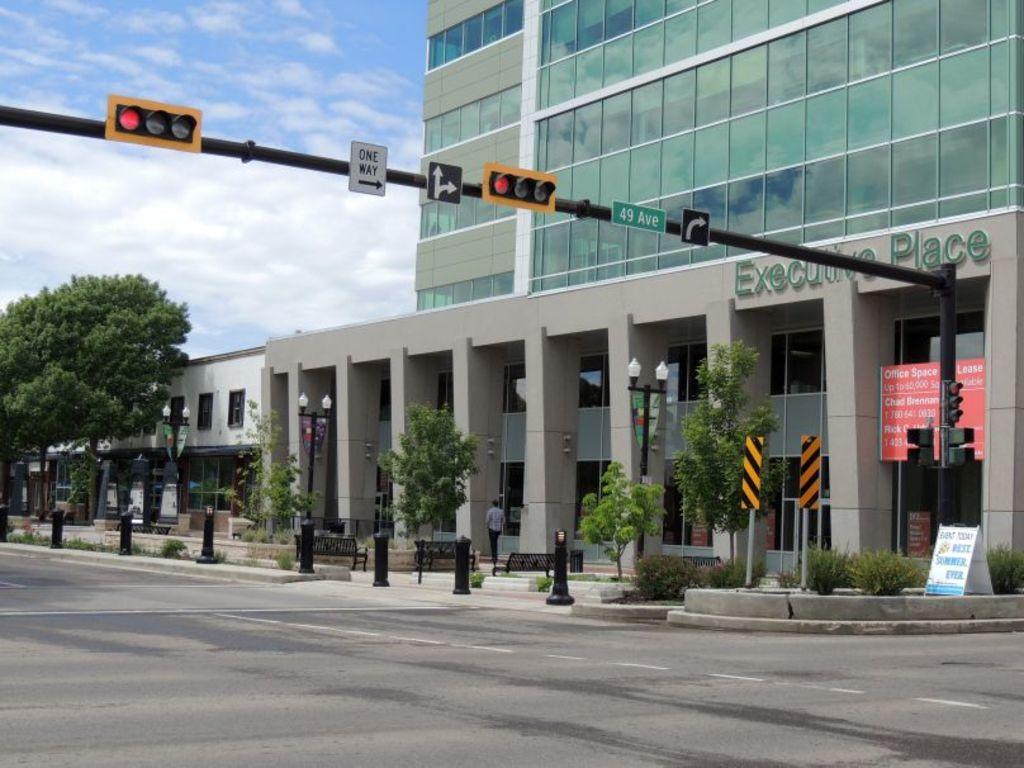What is the name of the building?
Keep it short and to the point. Executive place. The white sign in the middle says what way?
Give a very brief answer. One way. 